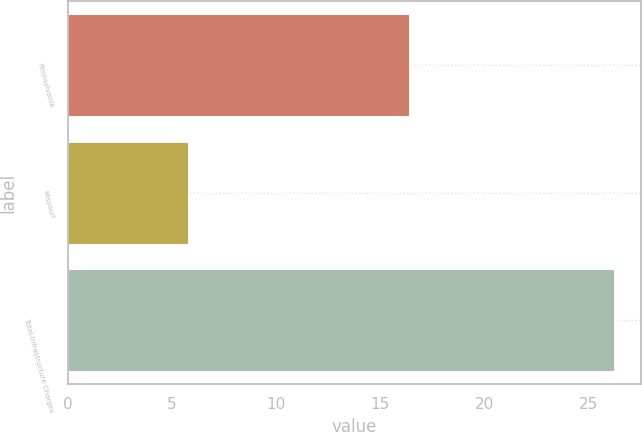Convert chart to OTSL. <chart><loc_0><loc_0><loc_500><loc_500><bar_chart><fcel>Pennsylvania<fcel>Missouri<fcel>Total-Infrastructure Charges<nl><fcel>16.4<fcel>5.8<fcel>26.2<nl></chart> 